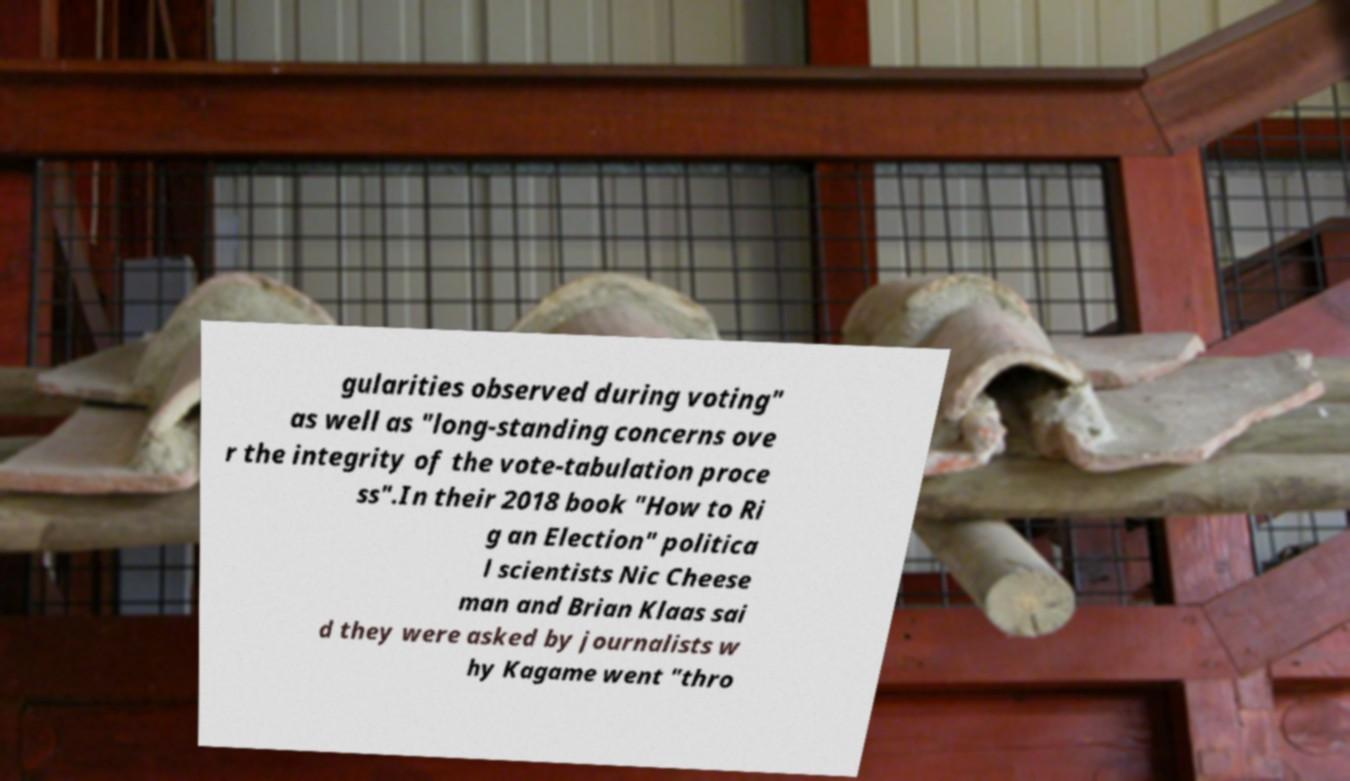Please read and relay the text visible in this image. What does it say? gularities observed during voting" as well as "long-standing concerns ove r the integrity of the vote-tabulation proce ss".In their 2018 book "How to Ri g an Election" politica l scientists Nic Cheese man and Brian Klaas sai d they were asked by journalists w hy Kagame went "thro 